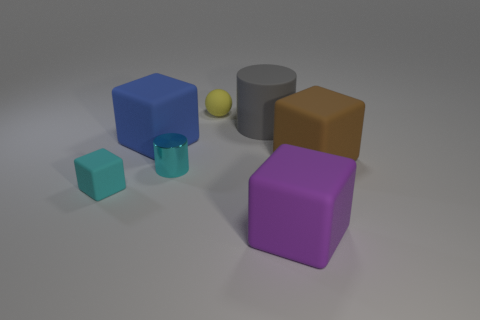There is a metallic object; is it the same color as the small rubber thing in front of the large brown rubber cube?
Make the answer very short. Yes. Are there any other things that have the same color as the metal object?
Your answer should be very brief. Yes. Is the purple thing made of the same material as the object that is right of the big purple thing?
Make the answer very short. Yes. There is a big brown rubber object to the right of the cyan cylinder to the left of the tiny yellow ball; what is its shape?
Offer a very short reply. Cube. The big thing that is both to the right of the blue rubber cube and left of the purple block has what shape?
Provide a short and direct response. Cylinder. How many things are either large cyan balls or large things right of the purple matte block?
Provide a succinct answer. 1. What is the material of the tiny cyan object that is the same shape as the big gray rubber thing?
Provide a succinct answer. Metal. Is there anything else that is made of the same material as the small cyan cylinder?
Give a very brief answer. No. There is a big thing that is both behind the brown rubber thing and on the right side of the small cyan metallic cylinder; what material is it?
Provide a succinct answer. Rubber. How many tiny blue matte objects are the same shape as the large gray object?
Make the answer very short. 0. 